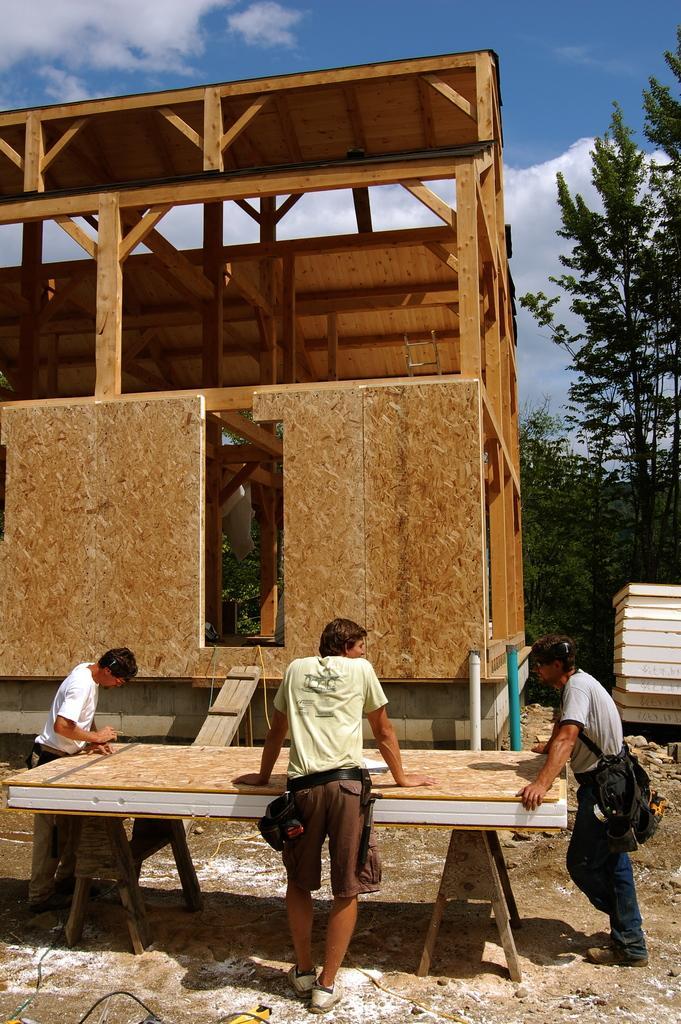In one or two sentences, can you explain what this image depicts? In this image I see 3 persons over here who are standing and I see a thing over here. In the background I see the wooden things and I see the trees and I see the sky. 